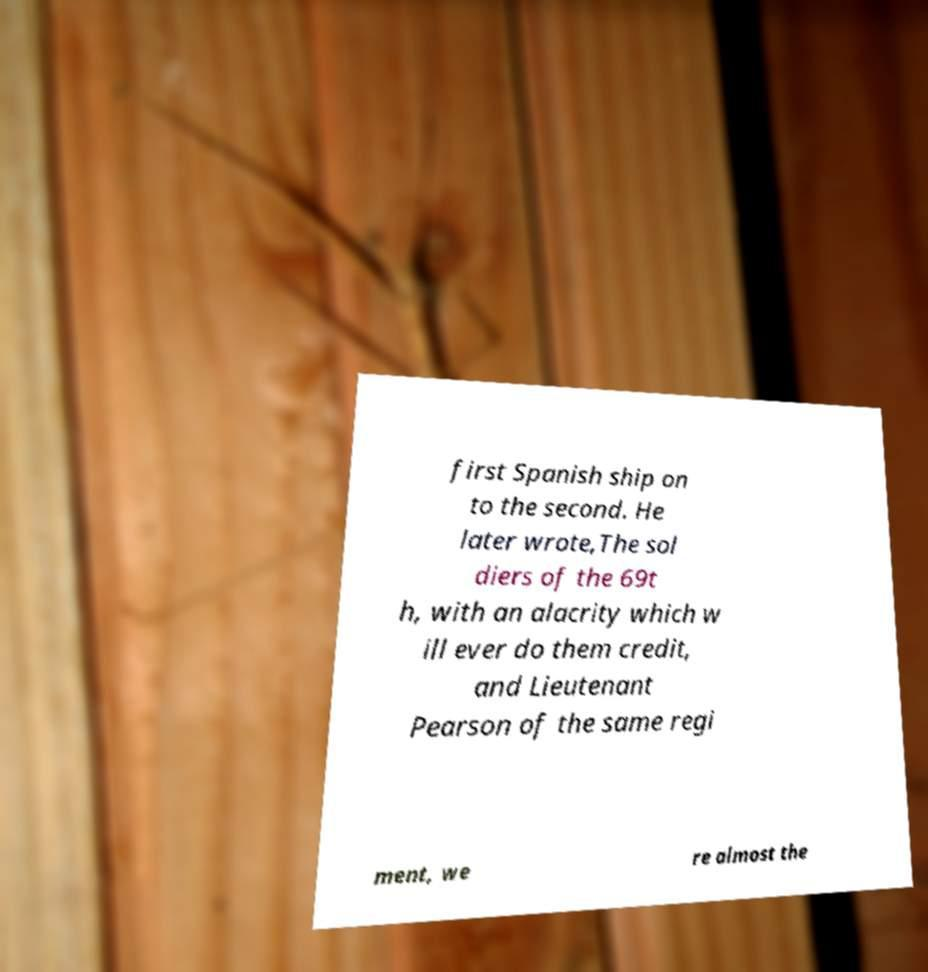Please identify and transcribe the text found in this image. first Spanish ship on to the second. He later wrote,The sol diers of the 69t h, with an alacrity which w ill ever do them credit, and Lieutenant Pearson of the same regi ment, we re almost the 